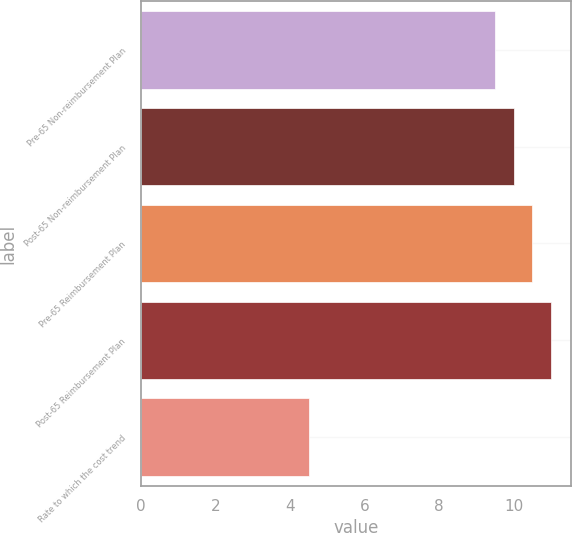Convert chart. <chart><loc_0><loc_0><loc_500><loc_500><bar_chart><fcel>Pre-65 Non-reimbursement Plan<fcel>Post-65 Non-reimbursement Plan<fcel>Pre-65 Reimbursement Plan<fcel>Post-65 Reimbursement Plan<fcel>Rate to which the cost trend<nl><fcel>9.5<fcel>10<fcel>10.5<fcel>11<fcel>4.5<nl></chart> 